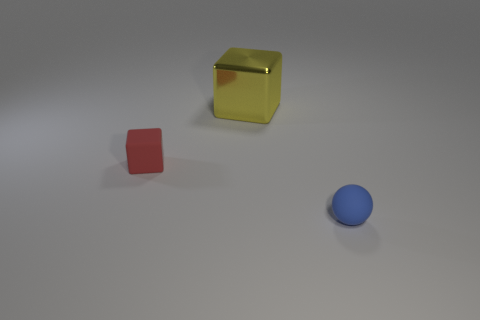What number of other things are there of the same shape as the small red rubber object?
Offer a terse response. 1. There is a yellow shiny thing; is its size the same as the matte object that is to the left of the big yellow block?
Your answer should be compact. No. How many things are small things that are on the right side of the tiny red object or large gray spheres?
Offer a very short reply. 1. The thing behind the small red block has what shape?
Your response must be concise. Cube. Are there the same number of yellow metallic objects that are behind the yellow shiny object and blue objects that are in front of the small red matte block?
Make the answer very short. No. There is a object that is both in front of the yellow object and to the right of the small red object; what color is it?
Ensure brevity in your answer.  Blue. There is a object to the right of the cube behind the tiny red block; what is it made of?
Provide a short and direct response. Rubber. Does the red block have the same size as the metallic object?
Give a very brief answer. No. What number of big things are yellow cubes or brown rubber blocks?
Your response must be concise. 1. There is a tiny blue matte ball; what number of blue balls are to the right of it?
Offer a terse response. 0. 